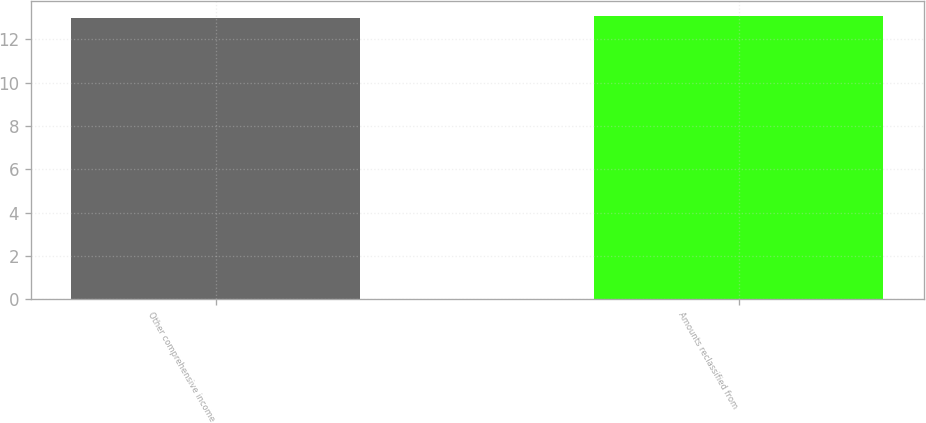Convert chart. <chart><loc_0><loc_0><loc_500><loc_500><bar_chart><fcel>Other comprehensive income<fcel>Amounts reclassified from<nl><fcel>13<fcel>13.1<nl></chart> 